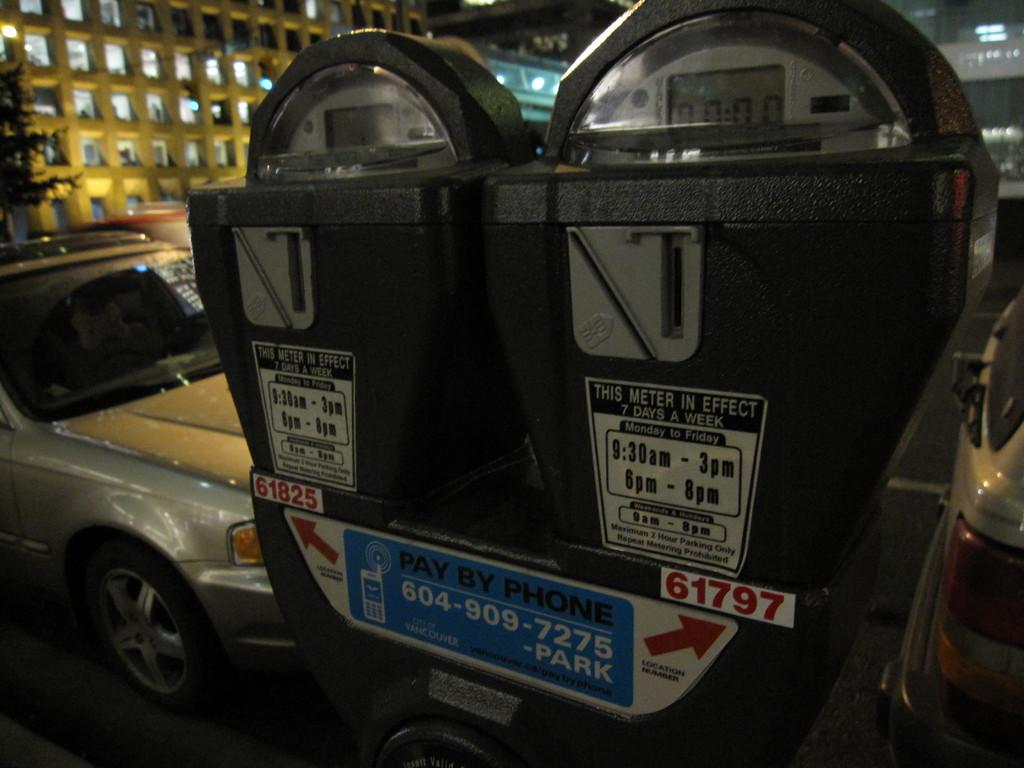What is the phone number on this meter?
Offer a very short reply. 604-909-7275. What is the number written in red on the right meter?
Your answer should be very brief. 61797. 